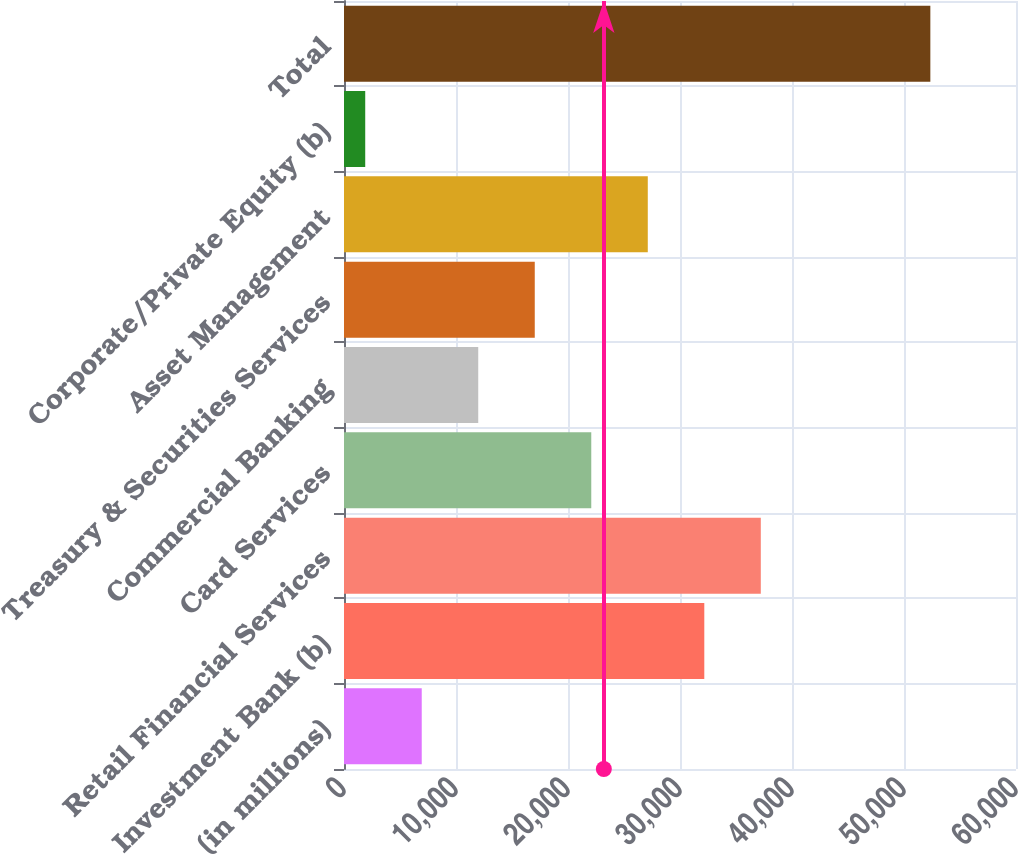Convert chart. <chart><loc_0><loc_0><loc_500><loc_500><bar_chart><fcel>(in millions)<fcel>Investment Bank (b)<fcel>Retail Financial Services<fcel>Card Services<fcel>Commercial Banking<fcel>Treasury & Securities Services<fcel>Asset Management<fcel>Corporate/Private Equity (b)<fcel>Total<nl><fcel>6940.7<fcel>32169.2<fcel>37214.9<fcel>22077.8<fcel>11986.4<fcel>17032.1<fcel>27123.5<fcel>1895<fcel>52352<nl></chart> 